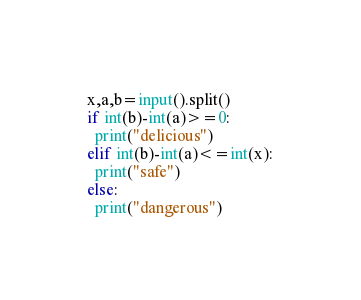Convert code to text. <code><loc_0><loc_0><loc_500><loc_500><_Python_>x,a,b=input().split()
if int(b)-int(a)>=0:
  print("delicious")
elif int(b)-int(a)<=int(x):
  print("safe")
else:
  print("dangerous")</code> 